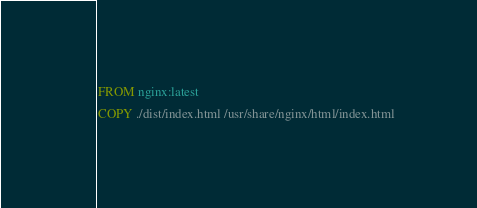<code> <loc_0><loc_0><loc_500><loc_500><_Dockerfile_>FROM nginx:latest
COPY ./dist/index.html /usr/share/nginx/html/index.html</code> 